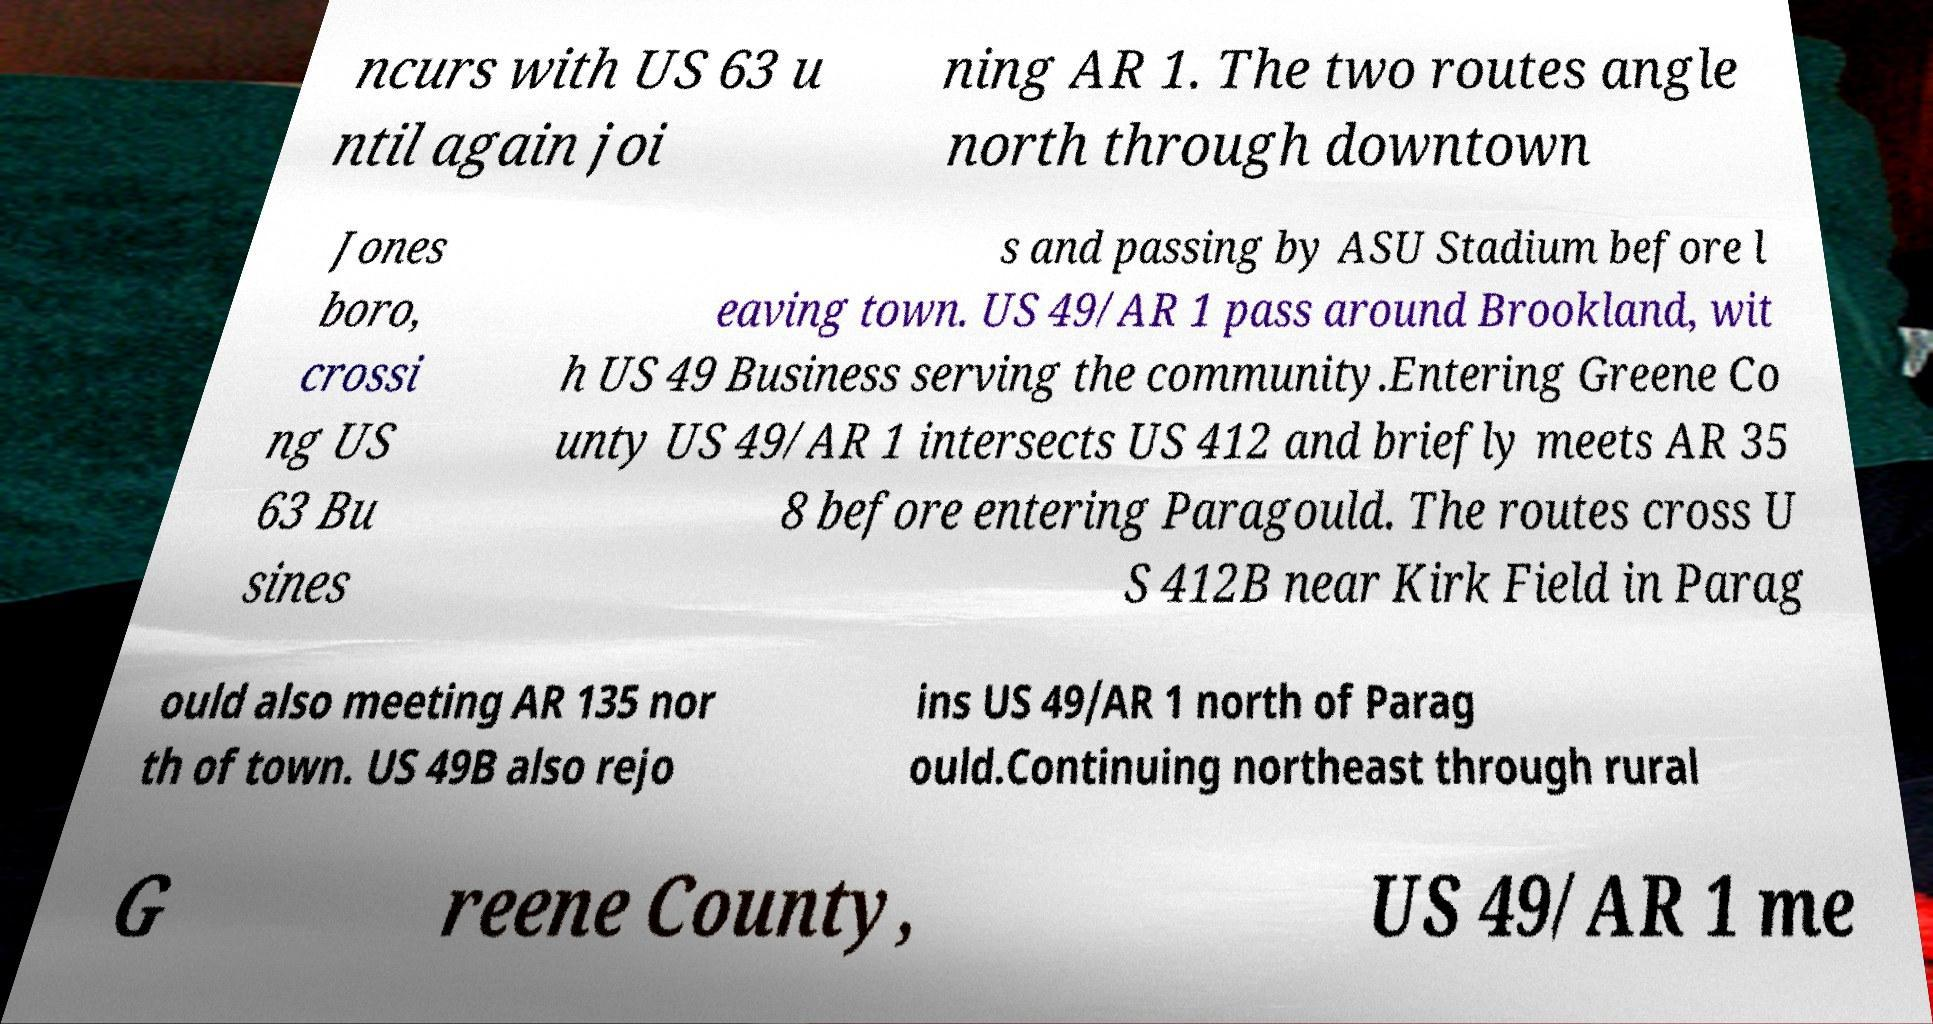There's text embedded in this image that I need extracted. Can you transcribe it verbatim? ncurs with US 63 u ntil again joi ning AR 1. The two routes angle north through downtown Jones boro, crossi ng US 63 Bu sines s and passing by ASU Stadium before l eaving town. US 49/AR 1 pass around Brookland, wit h US 49 Business serving the community.Entering Greene Co unty US 49/AR 1 intersects US 412 and briefly meets AR 35 8 before entering Paragould. The routes cross U S 412B near Kirk Field in Parag ould also meeting AR 135 nor th of town. US 49B also rejo ins US 49/AR 1 north of Parag ould.Continuing northeast through rural G reene County, US 49/AR 1 me 